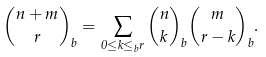Convert formula to latex. <formula><loc_0><loc_0><loc_500><loc_500>\binom { n + m } { r } _ { b } = \sum _ { 0 \leq k \leq _ { b } r } \binom { n } { k } _ { b } \binom { m } { r - k } _ { b } .</formula> 